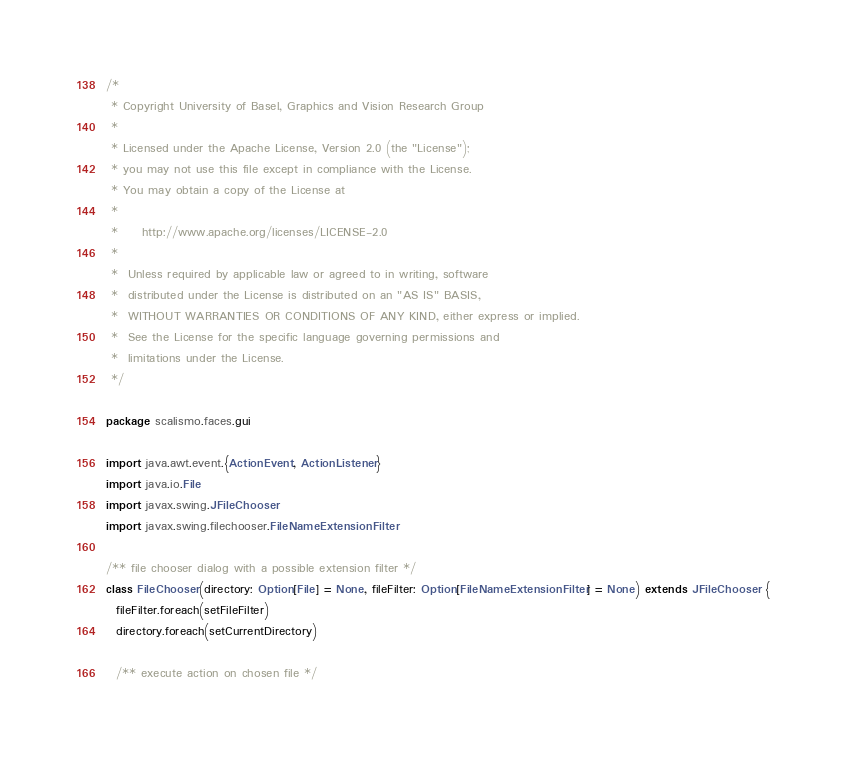<code> <loc_0><loc_0><loc_500><loc_500><_Scala_>/*
 * Copyright University of Basel, Graphics and Vision Research Group
 *
 * Licensed under the Apache License, Version 2.0 (the "License");
 * you may not use this file except in compliance with the License.
 * You may obtain a copy of the License at
 *
 *     http://www.apache.org/licenses/LICENSE-2.0
 *
 *  Unless required by applicable law or agreed to in writing, software
 *  distributed under the License is distributed on an "AS IS" BASIS,
 *  WITHOUT WARRANTIES OR CONDITIONS OF ANY KIND, either express or implied.
 *  See the License for the specific language governing permissions and
 *  limitations under the License.
 */

package scalismo.faces.gui

import java.awt.event.{ActionEvent, ActionListener}
import java.io.File
import javax.swing.JFileChooser
import javax.swing.filechooser.FileNameExtensionFilter

/** file chooser dialog with a possible extension filter */
class FileChooser(directory: Option[File] = None, fileFilter: Option[FileNameExtensionFilter] = None) extends JFileChooser {
  fileFilter.foreach(setFileFilter)
  directory.foreach(setCurrentDirectory)

  /** execute action on chosen file */</code> 